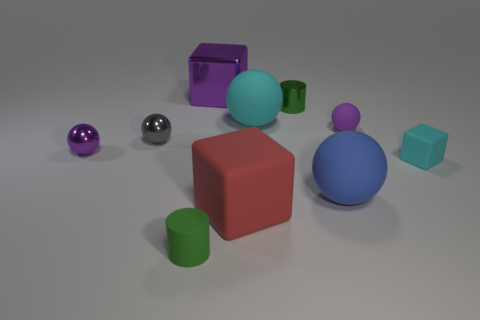Subtract all cylinders. How many objects are left? 8 Subtract all cyan rubber things. Subtract all small metal cylinders. How many objects are left? 7 Add 7 large red rubber objects. How many large red rubber objects are left? 8 Add 6 large red matte things. How many large red matte things exist? 7 Subtract 0 gray cylinders. How many objects are left? 10 